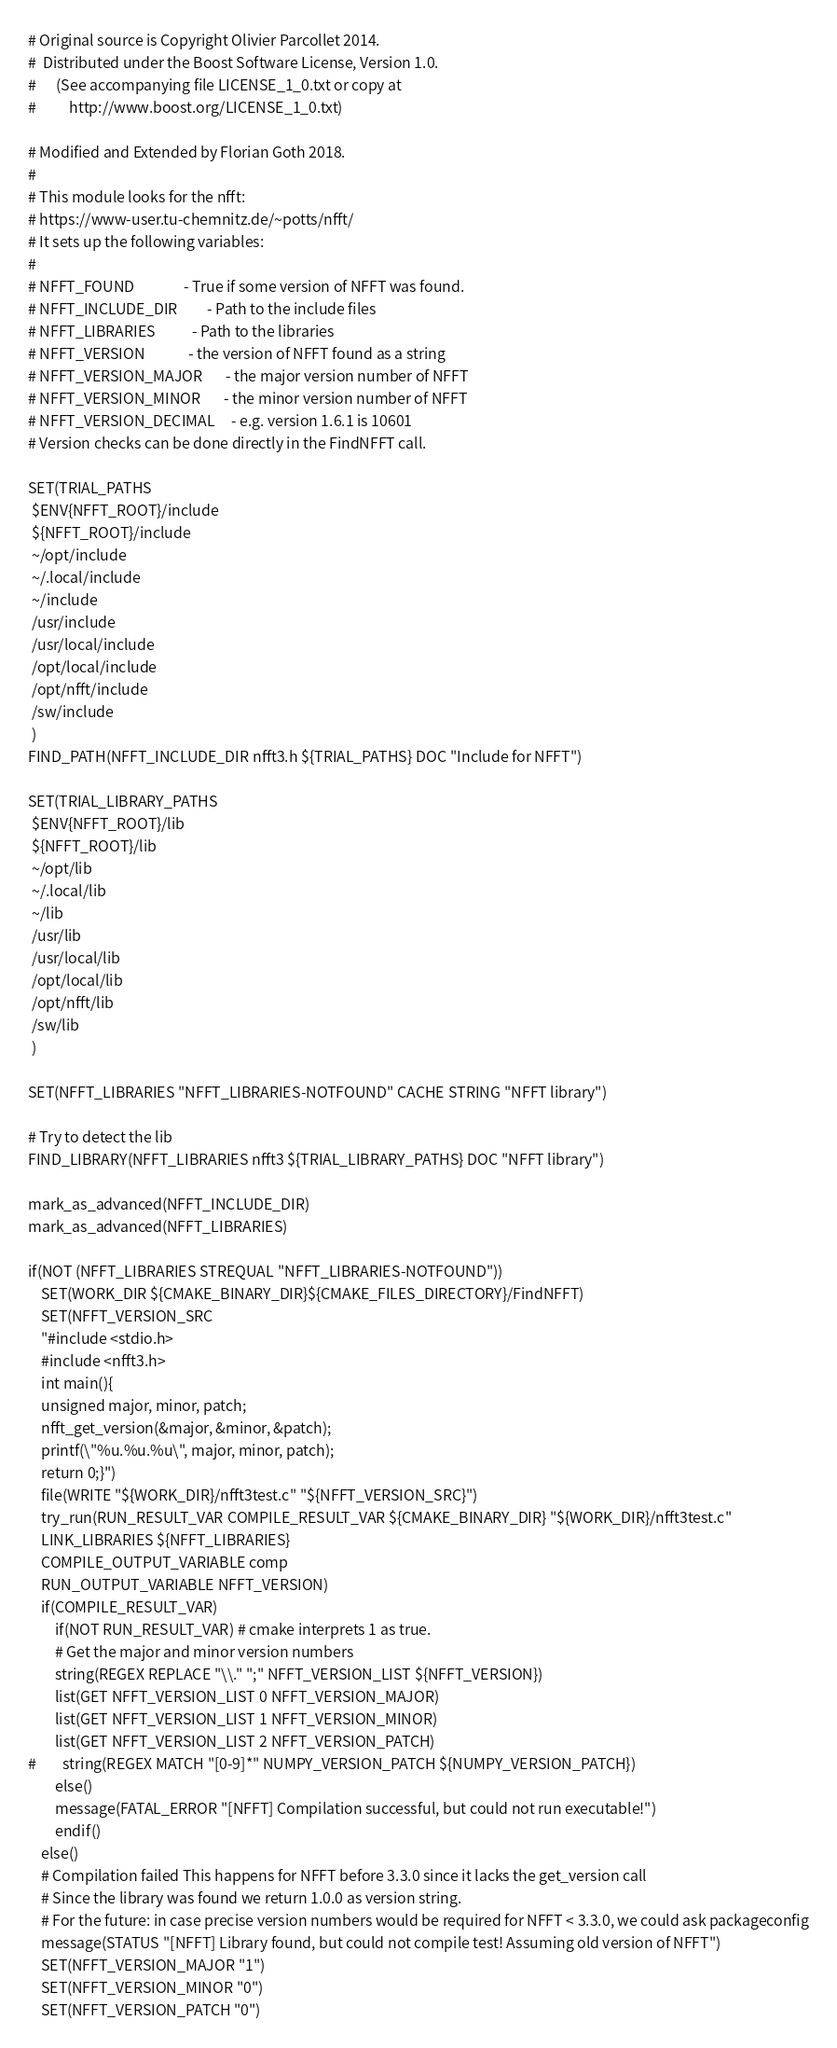Convert code to text. <code><loc_0><loc_0><loc_500><loc_500><_CMake_># Original source is Copyright Olivier Parcollet 2014.
#  Distributed under the Boost Software License, Version 1.0.
#      (See accompanying file LICENSE_1_0.txt or copy at
#          http://www.boost.org/LICENSE_1_0.txt)

# Modified and Extended by Florian Goth 2018.
#
# This module looks for the nfft:
# https://www-user.tu-chemnitz.de/~potts/nfft/
# It sets up the following variables:
#
# NFFT_FOUND               - True if some version of NFFT was found.
# NFFT_INCLUDE_DIR         - Path to the include files
# NFFT_LIBRARIES           - Path to the libraries
# NFFT_VERSION             - the version of NFFT found as a string
# NFFT_VERSION_MAJOR       - the major version number of NFFT
# NFFT_VERSION_MINOR       - the minor version number of NFFT
# NFFT_VERSION_DECIMAL     - e.g. version 1.6.1 is 10601
# Version checks can be done directly in the FindNFFT call.

SET(TRIAL_PATHS
 $ENV{NFFT_ROOT}/include
 ${NFFT_ROOT}/include
 ~/opt/include
 ~/.local/include
 ~/include
 /usr/include
 /usr/local/include
 /opt/local/include
 /opt/nfft/include
 /sw/include
 )
FIND_PATH(NFFT_INCLUDE_DIR nfft3.h ${TRIAL_PATHS} DOC "Include for NFFT")

SET(TRIAL_LIBRARY_PATHS
 $ENV{NFFT_ROOT}/lib
 ${NFFT_ROOT}/lib
 ~/opt/lib
 ~/.local/lib
 ~/lib
 /usr/lib 
 /usr/local/lib
 /opt/local/lib
 /opt/nfft/lib
 /sw/lib
 )

SET(NFFT_LIBRARIES "NFFT_LIBRARIES-NOTFOUND" CACHE STRING "NFFT library")

# Try to detect the lib
FIND_LIBRARY(NFFT_LIBRARIES nfft3 ${TRIAL_LIBRARY_PATHS} DOC "NFFT library")

mark_as_advanced(NFFT_INCLUDE_DIR)
mark_as_advanced(NFFT_LIBRARIES)

if(NOT (NFFT_LIBRARIES STREQUAL "NFFT_LIBRARIES-NOTFOUND"))
    SET(WORK_DIR ${CMAKE_BINARY_DIR}${CMAKE_FILES_DIRECTORY}/FindNFFT)
    SET(NFFT_VERSION_SRC 
    "#include <stdio.h>
    #include <nfft3.h>
    int main(){
    unsigned major, minor, patch;
    nfft_get_version(&major, &minor, &patch);
    printf(\"%u.%u.%u\", major, minor, patch);
    return 0;}")
    file(WRITE "${WORK_DIR}/nfft3test.c" "${NFFT_VERSION_SRC}")
    try_run(RUN_RESULT_VAR COMPILE_RESULT_VAR ${CMAKE_BINARY_DIR} "${WORK_DIR}/nfft3test.c"
    LINK_LIBRARIES ${NFFT_LIBRARIES}
    COMPILE_OUTPUT_VARIABLE comp
    RUN_OUTPUT_VARIABLE NFFT_VERSION)
    if(COMPILE_RESULT_VAR)
        if(NOT RUN_RESULT_VAR) # cmake interprets 1 as true. 
        # Get the major and minor version numbers
        string(REGEX REPLACE "\\." ";" NFFT_VERSION_LIST ${NFFT_VERSION})
        list(GET NFFT_VERSION_LIST 0 NFFT_VERSION_MAJOR)
        list(GET NFFT_VERSION_LIST 1 NFFT_VERSION_MINOR)
        list(GET NFFT_VERSION_LIST 2 NFFT_VERSION_PATCH)
#        string(REGEX MATCH "[0-9]*" NUMPY_VERSION_PATCH ${NUMPY_VERSION_PATCH})        
        else()
        message(FATAL_ERROR "[NFFT] Compilation successful, but could not run executable!")
        endif()
    else()
    # Compilation failed This happens for NFFT before 3.3.0 since it lacks the get_version call
    # Since the library was found we return 1.0.0 as version string.
    # For the future: in case precise version numbers would be required for NFFT < 3.3.0, we could ask packageconfig
    message(STATUS "[NFFT] Library found, but could not compile test! Assuming old version of NFFT")
    SET(NFFT_VERSION_MAJOR "1")
    SET(NFFT_VERSION_MINOR "0")
    SET(NFFT_VERSION_PATCH "0")</code> 